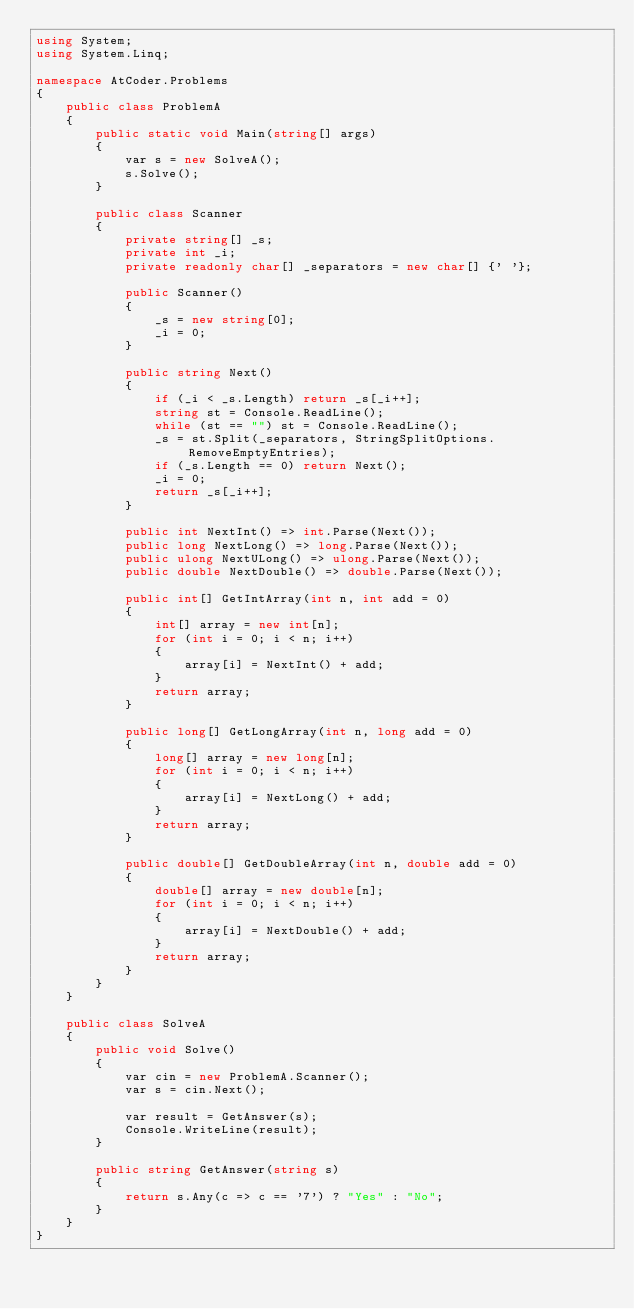<code> <loc_0><loc_0><loc_500><loc_500><_C#_>using System;
using System.Linq;

namespace AtCoder.Problems
{
    public class ProblemA
    {
        public static void Main(string[] args)
        {
            var s = new SolveA();
            s.Solve();
        }

        public class Scanner
        {
            private string[] _s;
            private int _i;
            private readonly char[] _separators = new char[] {' '};

            public Scanner()
            {
                _s = new string[0];
                _i = 0;
            }

            public string Next()
            {
                if (_i < _s.Length) return _s[_i++];
                string st = Console.ReadLine();
                while (st == "") st = Console.ReadLine();
                _s = st.Split(_separators, StringSplitOptions.RemoveEmptyEntries);
                if (_s.Length == 0) return Next();
                _i = 0;
                return _s[_i++];
            }

            public int NextInt() => int.Parse(Next());
            public long NextLong() => long.Parse(Next());
            public ulong NextULong() => ulong.Parse(Next());
            public double NextDouble() => double.Parse(Next());

            public int[] GetIntArray(int n, int add = 0)
            {
                int[] array = new int[n];
                for (int i = 0; i < n; i++)
                {
                    array[i] = NextInt() + add;
                }
                return array;
            }

            public long[] GetLongArray(int n, long add = 0)
            {
                long[] array = new long[n];
                for (int i = 0; i < n; i++)
                {
                    array[i] = NextLong() + add;
                }
                return array;
            }

            public double[] GetDoubleArray(int n, double add = 0)
            {
                double[] array = new double[n];
                for (int i = 0; i < n; i++)
                {
                    array[i] = NextDouble() + add;
                }
                return array;
            }
        }
    }

    public class SolveA
    {
        public void Solve()
        {
            var cin = new ProblemA.Scanner();
            var s = cin.Next();

            var result = GetAnswer(s);
            Console.WriteLine(result);
        }

        public string GetAnswer(string s)
        {
            return s.Any(c => c == '7') ? "Yes" : "No";
        }
    }
}</code> 